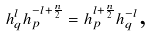<formula> <loc_0><loc_0><loc_500><loc_500>h _ { q } ^ { l } h _ { p } ^ { - l + \frac { n } { 2 } } = h _ { p } ^ { l + \frac { n } { 2 } } h _ { q } ^ { - l } \text {,}</formula> 